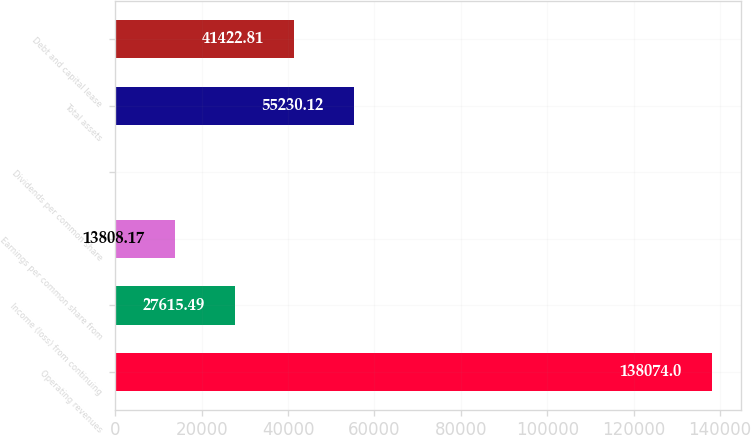Convert chart. <chart><loc_0><loc_0><loc_500><loc_500><bar_chart><fcel>Operating revenues<fcel>Income (loss) from continuing<fcel>Earnings per common share from<fcel>Dividends per common share<fcel>Total assets<fcel>Debt and capital lease<nl><fcel>138074<fcel>27615.5<fcel>13808.2<fcel>0.85<fcel>55230.1<fcel>41422.8<nl></chart> 